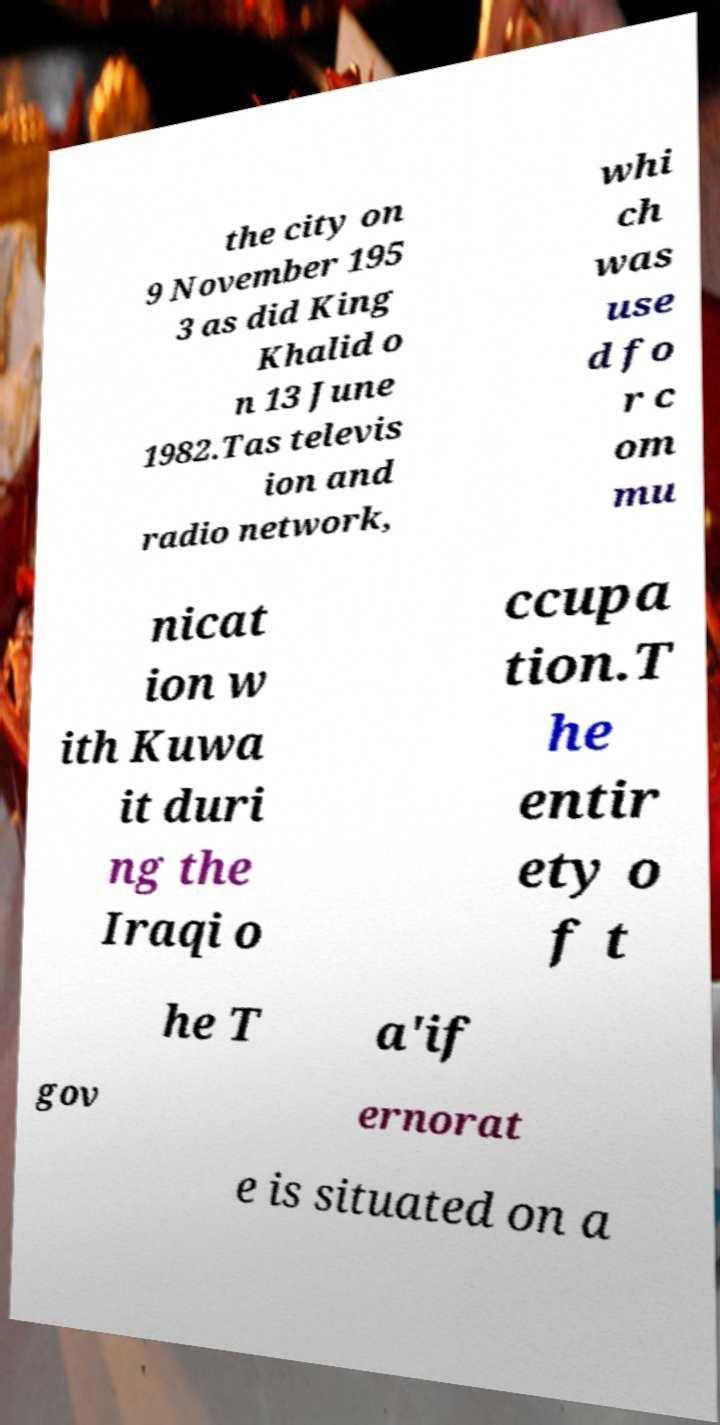Can you accurately transcribe the text from the provided image for me? the city on 9 November 195 3 as did King Khalid o n 13 June 1982.Tas televis ion and radio network, whi ch was use d fo r c om mu nicat ion w ith Kuwa it duri ng the Iraqi o ccupa tion.T he entir ety o f t he T a'if gov ernorat e is situated on a 